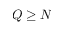<formula> <loc_0><loc_0><loc_500><loc_500>Q \geq N</formula> 